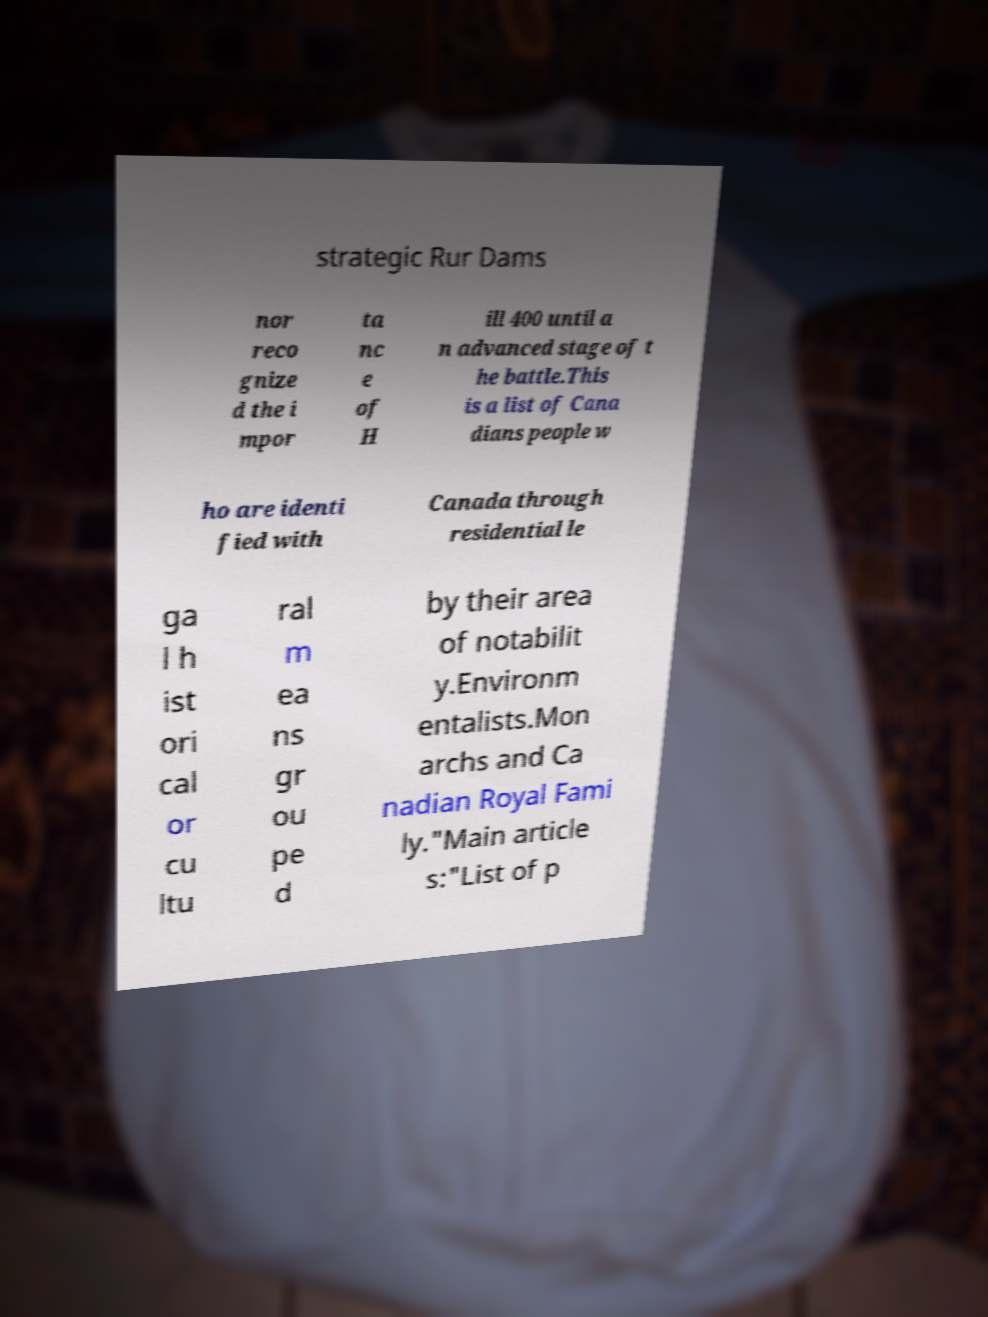Could you assist in decoding the text presented in this image and type it out clearly? strategic Rur Dams nor reco gnize d the i mpor ta nc e of H ill 400 until a n advanced stage of t he battle.This is a list of Cana dians people w ho are identi fied with Canada through residential le ga l h ist ori cal or cu ltu ral m ea ns gr ou pe d by their area of notabilit y.Environm entalists.Mon archs and Ca nadian Royal Fami ly."Main article s:"List of p 